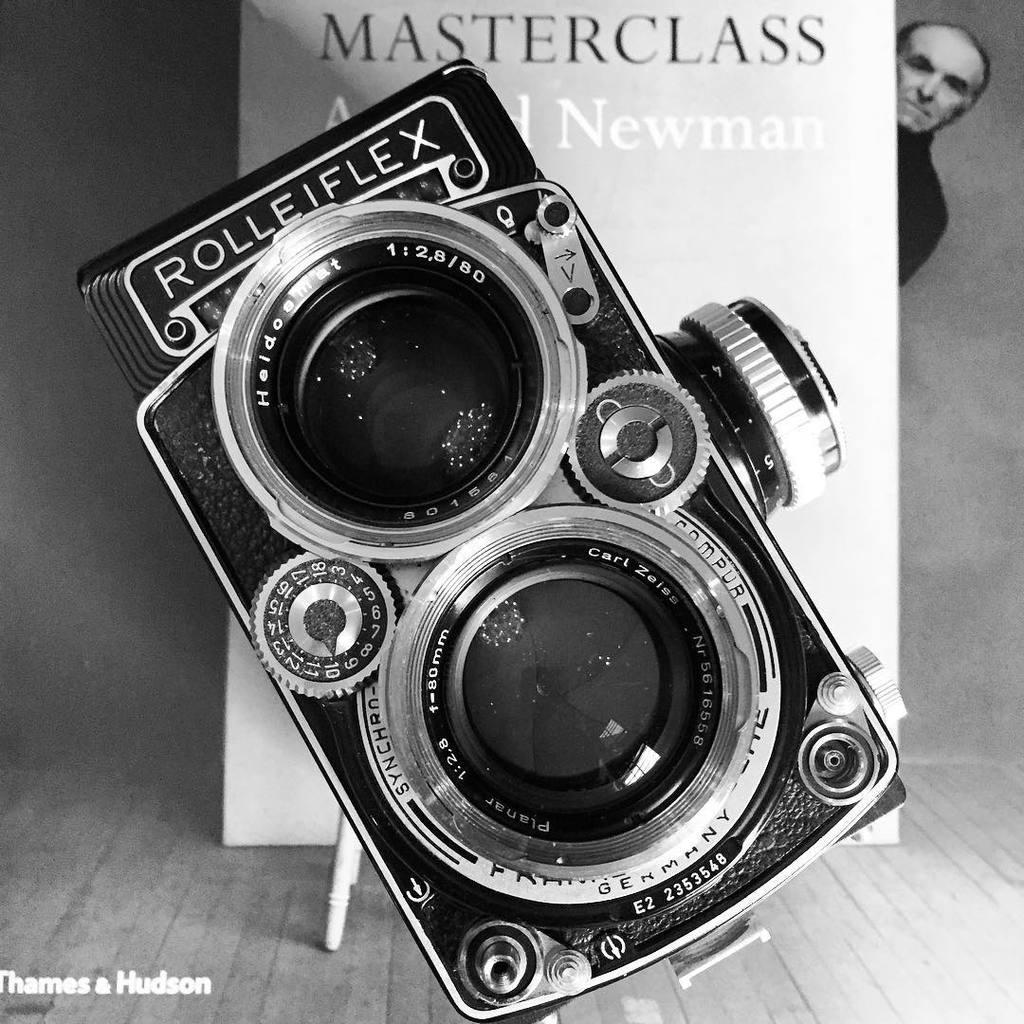What object is located in the foreground of the image? There is a camera in the foreground of the image. What can be seen on the poster in the image? There is a poster of a man in the image. What is the purpose of the whiteboard in the image? The whiteboard in the image is likely used for writing or displaying information. What type of silver substance is present on the camera in the image? There is no silver substance present on the camera in the image. What mark can be seen on the poster of the man in the image? There is no specific mark mentioned on the poster of the man in the image. 